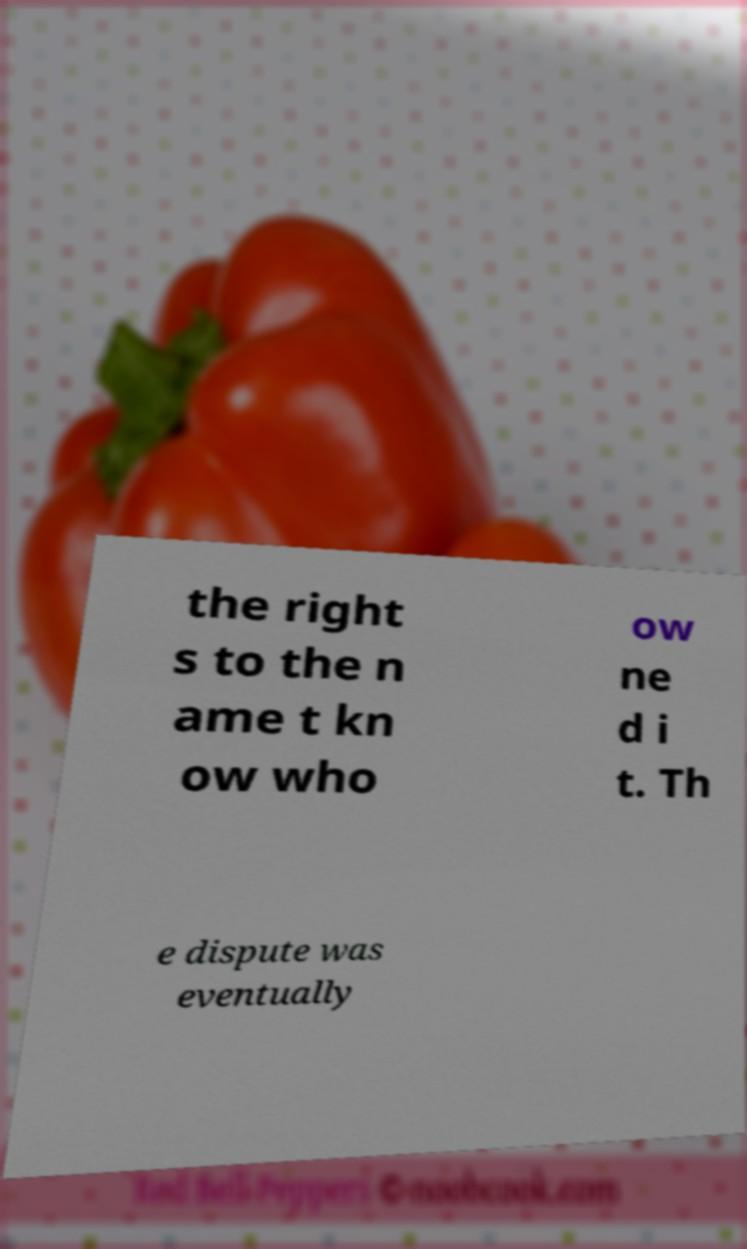Can you accurately transcribe the text from the provided image for me? the right s to the n ame t kn ow who ow ne d i t. Th e dispute was eventually 